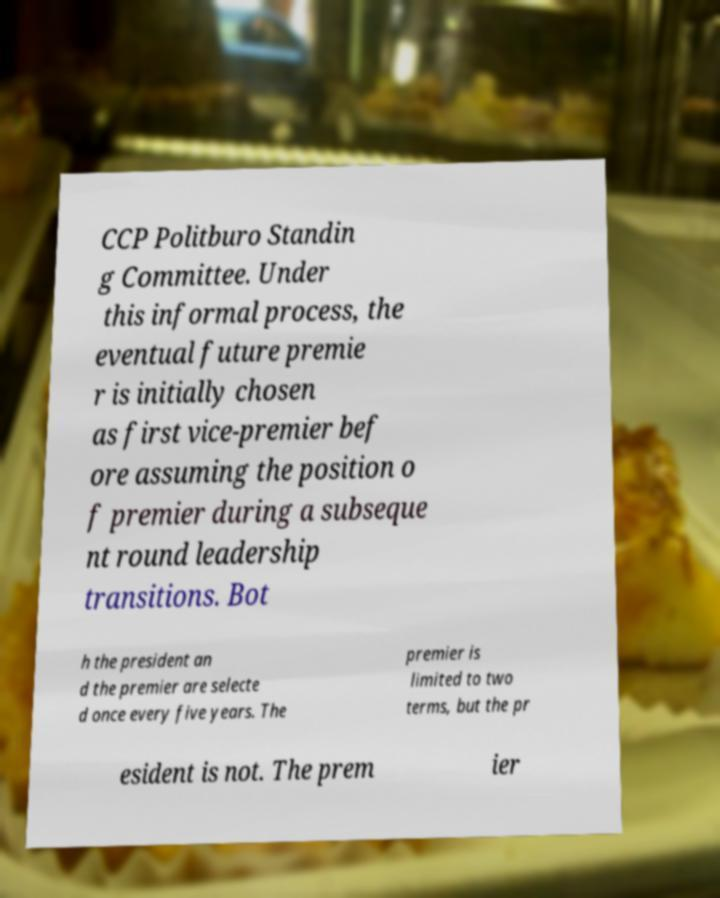For documentation purposes, I need the text within this image transcribed. Could you provide that? CCP Politburo Standin g Committee. Under this informal process, the eventual future premie r is initially chosen as first vice-premier bef ore assuming the position o f premier during a subseque nt round leadership transitions. Bot h the president an d the premier are selecte d once every five years. The premier is limited to two terms, but the pr esident is not. The prem ier 